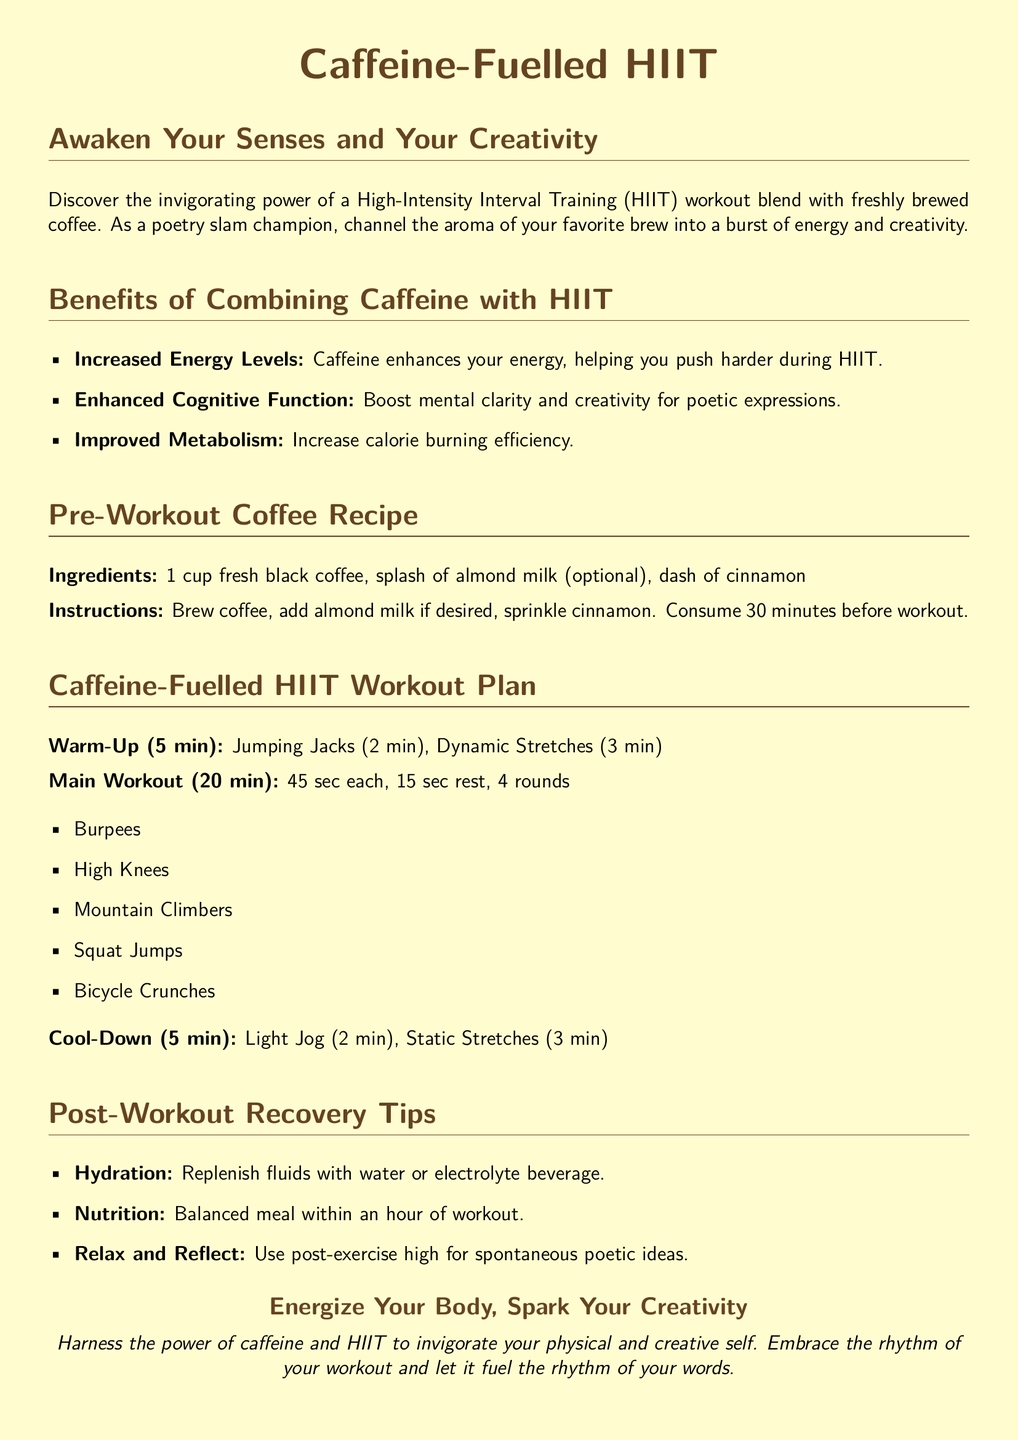What is the main focus of Caffeine-Fuelled HIIT? The main focus is on combining High-Intensity Interval Training with caffeine to energize the body and spark creativity.
Answer: Energize your body, spark your creativity What are the ingredients for the pre-workout coffee recipe? The ingredients mentioned are fresh black coffee, almond milk (optional), and cinnamon.
Answer: Fresh black coffee, almond milk (optional), cinnamon How long does the main workout last? The document specifies that the main workout lasts for 20 minutes.
Answer: 20 minutes What exercise is performed for 2 minutes during the warm-up? The warm-up includes Jumping Jacks for 2 minutes.
Answer: Jumping Jacks How many rounds are included in the main workout? The main workout includes 4 rounds of exercises.
Answer: 4 rounds What should be consumed 30 minutes before the workout? The document states to consume a pre-workout coffee 30 minutes prior.
Answer: Pre-workout coffee What is one post-workout recovery tip mentioned? One recovery tip includes rehydration following the exercise.
Answer: Hydration What is the duration of the cool-down period? The cool-down period lasts for 5 minutes according to the document.
Answer: 5 minutes What is the effect of caffeine on cognitive function according to the document? Caffeine enhances cognitive function, boosting mental clarity and creativity.
Answer: Enhanced cognitive function 